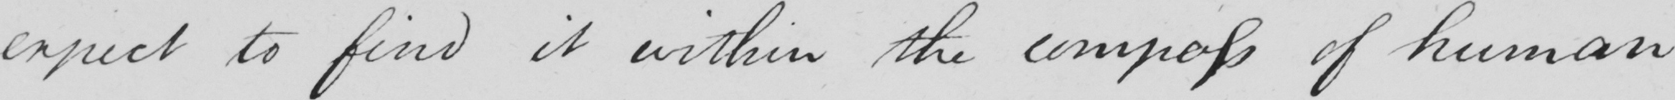What does this handwritten line say? expect to find it within the compass of human 